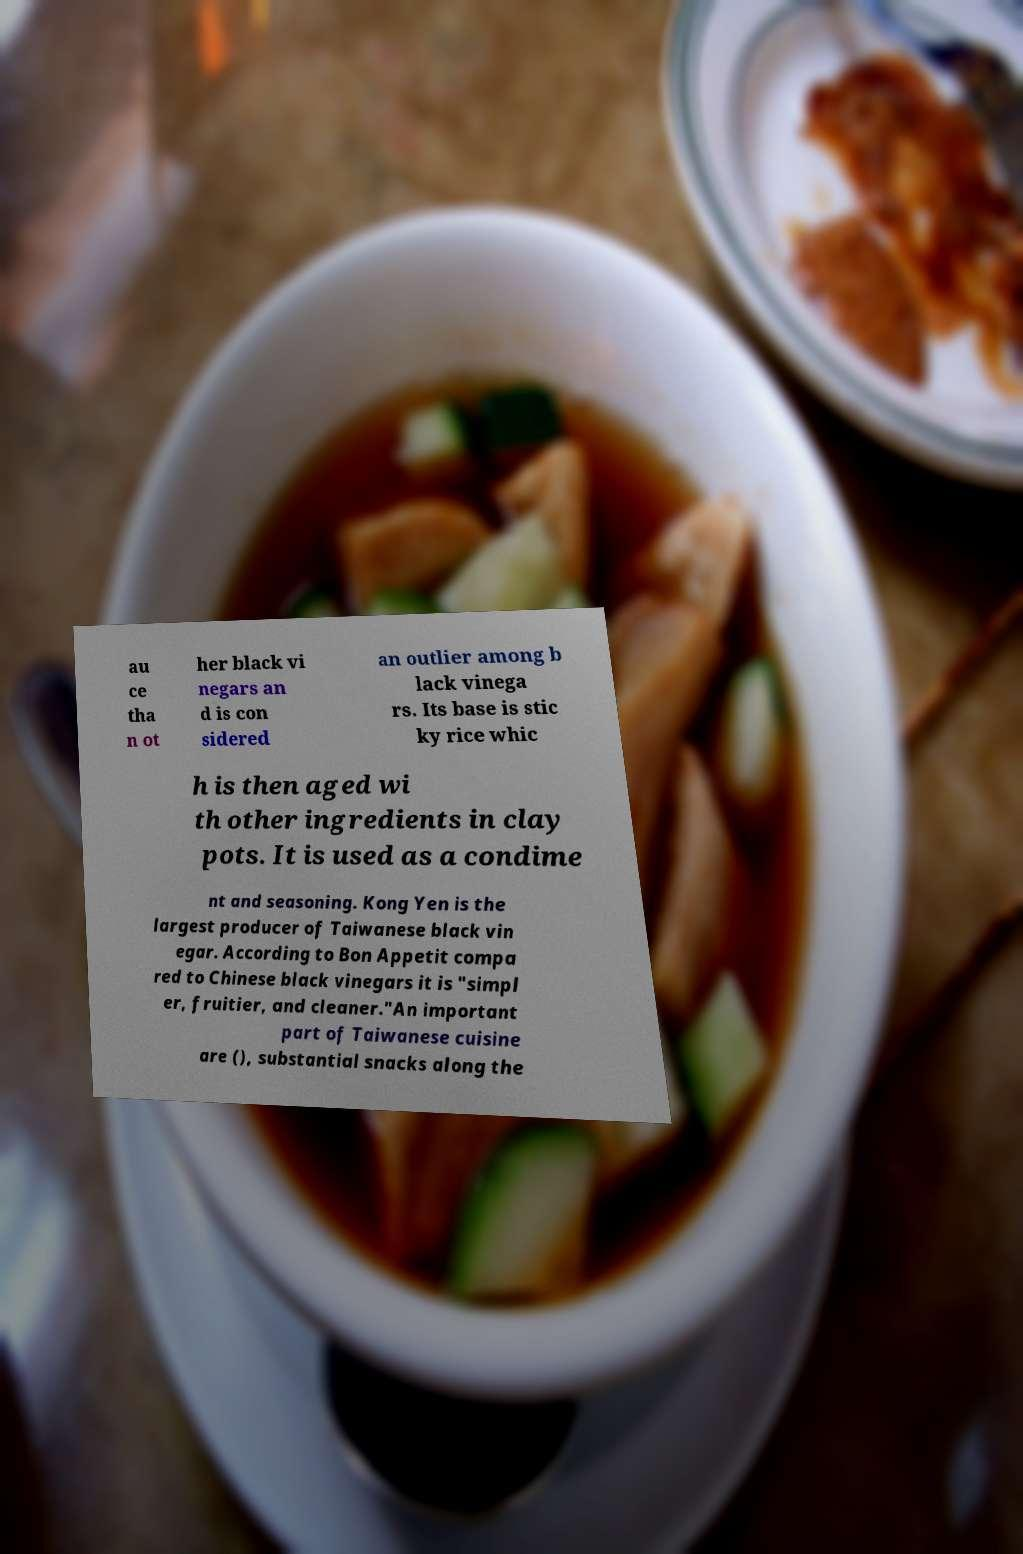For documentation purposes, I need the text within this image transcribed. Could you provide that? au ce tha n ot her black vi negars an d is con sidered an outlier among b lack vinega rs. Its base is stic ky rice whic h is then aged wi th other ingredients in clay pots. It is used as a condime nt and seasoning. Kong Yen is the largest producer of Taiwanese black vin egar. According to Bon Appetit compa red to Chinese black vinegars it is "simpl er, fruitier, and cleaner."An important part of Taiwanese cuisine are (), substantial snacks along the 